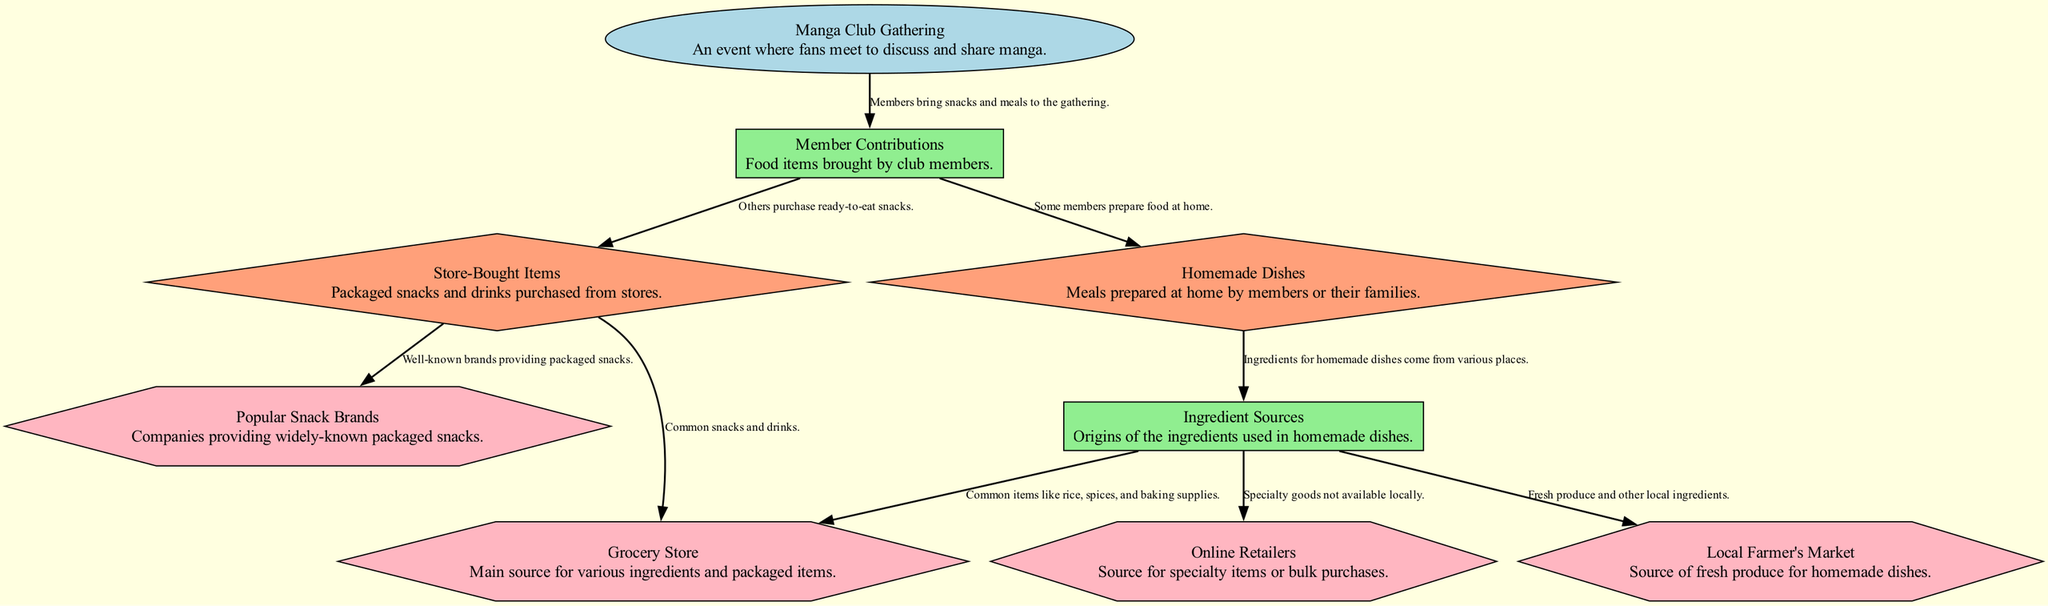What is the main event depicted in the diagram? The diagram indicates that the main event is the "Manga Club Gathering," as this node is at the top and clearly labeled as an event.
Answer: Manga Club Gathering How many types of food contributions are there? There are two types of food contributions shown in the diagram: "Homemade Dishes" and "Store-Bought Items," as evidenced by the two edges pointing from "Member Contributions."
Answer: 2 What do "Homemade Dishes" use for their ingredients? The diagram shows that "Homemade Dishes" rely on multiple "Ingredient Sources," where these sources are detailed as places where the ingredients come from.
Answer: Ingredient Sources Which type of food contribution includes items from well-known brands? The "Store-Bought Items" category includes items from "Popular Snack Brands," which is specifically mentioned in the diagram linking these two nodes.
Answer: Store-Bought Items What sources provide ingredients for homemade dishes? The "Ingredient Sources" for homemade dishes include "Local Farmer's Market," "Grocery Store," and "Online Retailers," based on the edges leading out from "Ingredient Sources."
Answer: Local Farmer's Market, Grocery Store, Online Retailers Which node represents the collection of food items brought by members? The "Member Contributions" node represents the collection of food items, as it is directly labeled as such and connected to the main event.
Answer: Member Contributions How does the diagram differentiate between homemade and store-bought contributions? The diagram differentiates by dividing contributions into two categories: "Homemade Dishes" for items made by members and "Store-Bought Items" for pre-packaged snacks, each clearly defined in the hierarchy.
Answer: By categories From where are snacks typically purchased according to the diagram? Snacks are typically purchased from "Grocery Store" as indicated by the link from "Store-Bought Items," which is part of the food sourcing representation.
Answer: Grocery Store What shapes are used to represent the types of sources in this diagram? The diagram uses hexagons to depict the types of sources, as indicated by their design style specified in the node attributes within the code.
Answer: Hexagons 